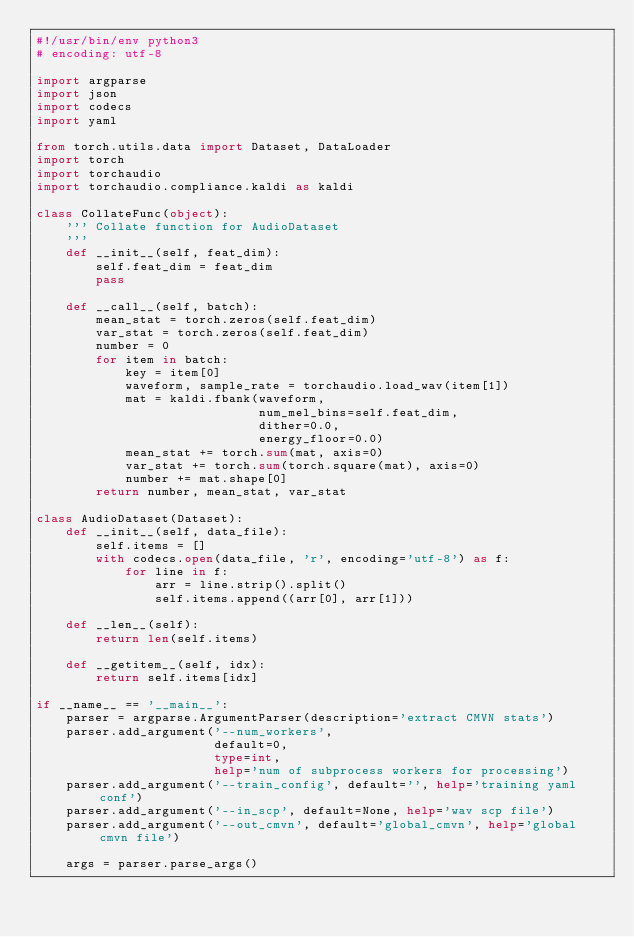Convert code to text. <code><loc_0><loc_0><loc_500><loc_500><_Python_>#!/usr/bin/env python3
# encoding: utf-8

import argparse
import json
import codecs
import yaml

from torch.utils.data import Dataset, DataLoader
import torch
import torchaudio
import torchaudio.compliance.kaldi as kaldi

class CollateFunc(object):
    ''' Collate function for AudioDataset
    '''
    def __init__(self, feat_dim):
        self.feat_dim = feat_dim
        pass

    def __call__(self, batch):
        mean_stat = torch.zeros(self.feat_dim)
        var_stat = torch.zeros(self.feat_dim)
        number = 0
        for item in batch:
            key = item[0]
            waveform, sample_rate = torchaudio.load_wav(item[1])
            mat = kaldi.fbank(waveform,
                              num_mel_bins=self.feat_dim,
                              dither=0.0,
                              energy_floor=0.0)
            mean_stat += torch.sum(mat, axis=0)
            var_stat += torch.sum(torch.square(mat), axis=0)
            number += mat.shape[0]
        return number, mean_stat, var_stat

class AudioDataset(Dataset):
    def __init__(self, data_file):
        self.items = []
        with codecs.open(data_file, 'r', encoding='utf-8') as f:
            for line in f:
                arr = line.strip().split()
                self.items.append((arr[0], arr[1]))

    def __len__(self):
        return len(self.items)

    def __getitem__(self, idx):
        return self.items[idx]

if __name__ == '__main__':
    parser = argparse.ArgumentParser(description='extract CMVN stats')
    parser.add_argument('--num_workers',
                        default=0,
                        type=int,
                        help='num of subprocess workers for processing')
    parser.add_argument('--train_config', default='', help='training yaml conf')
    parser.add_argument('--in_scp', default=None, help='wav scp file')
    parser.add_argument('--out_cmvn', default='global_cmvn', help='global cmvn file')

    args = parser.parse_args()
</code> 